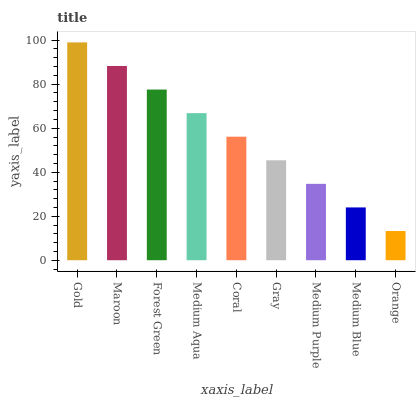Is Orange the minimum?
Answer yes or no. Yes. Is Gold the maximum?
Answer yes or no. Yes. Is Maroon the minimum?
Answer yes or no. No. Is Maroon the maximum?
Answer yes or no. No. Is Gold greater than Maroon?
Answer yes or no. Yes. Is Maroon less than Gold?
Answer yes or no. Yes. Is Maroon greater than Gold?
Answer yes or no. No. Is Gold less than Maroon?
Answer yes or no. No. Is Coral the high median?
Answer yes or no. Yes. Is Coral the low median?
Answer yes or no. Yes. Is Medium Blue the high median?
Answer yes or no. No. Is Maroon the low median?
Answer yes or no. No. 